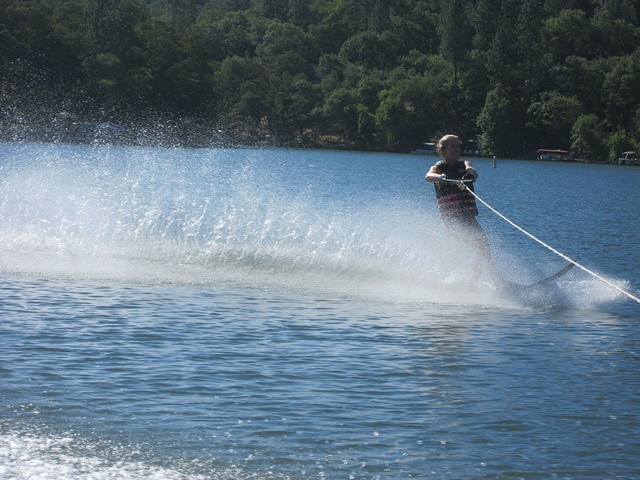Describe the objects in this image and their specific colors. I can see people in black, darkgray, and gray tones in this image. 